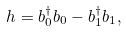<formula> <loc_0><loc_0><loc_500><loc_500>h = b ^ { \dagger } _ { 0 } b _ { 0 } - b ^ { \dagger } _ { 1 } b _ { 1 } ,</formula> 